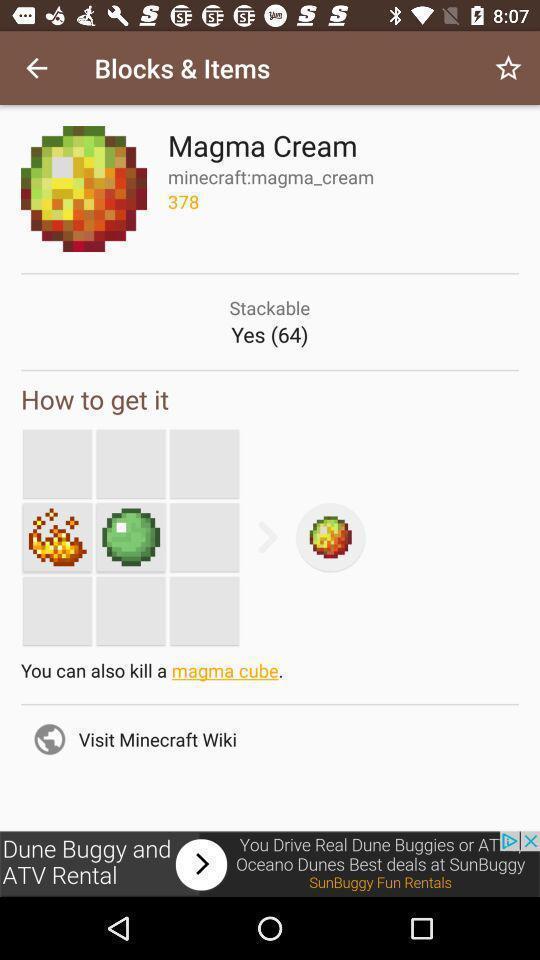Give me a summary of this screen capture. Page displaying how to kill magma cube. 